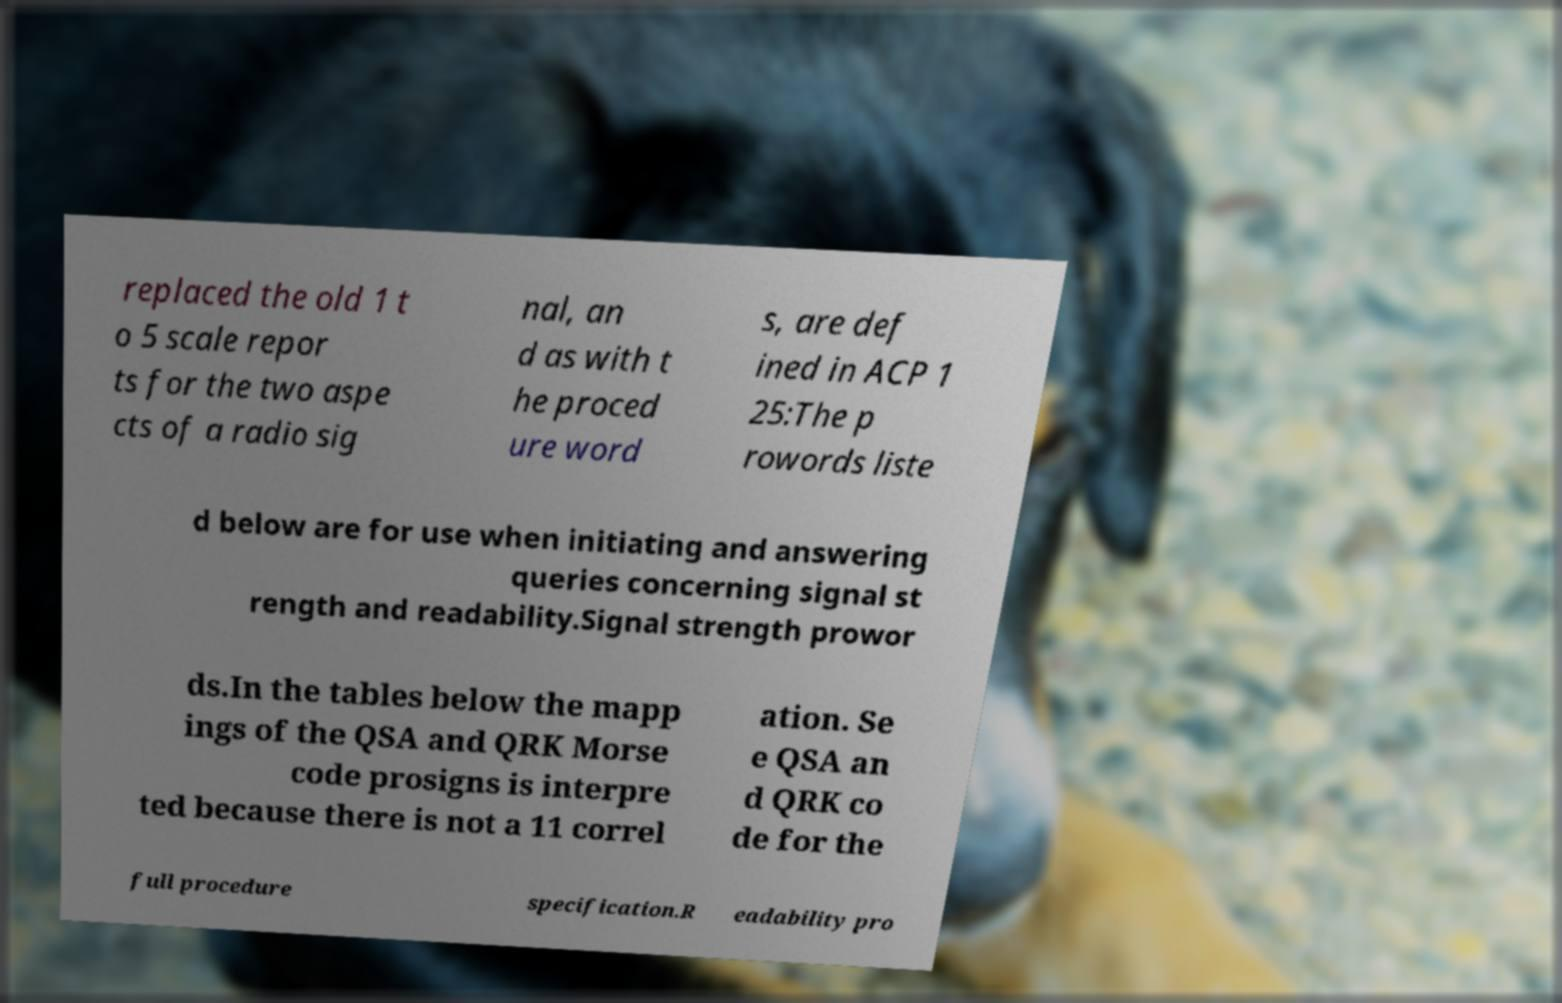There's text embedded in this image that I need extracted. Can you transcribe it verbatim? replaced the old 1 t o 5 scale repor ts for the two aspe cts of a radio sig nal, an d as with t he proced ure word s, are def ined in ACP 1 25:The p rowords liste d below are for use when initiating and answering queries concerning signal st rength and readability.Signal strength prowor ds.In the tables below the mapp ings of the QSA and QRK Morse code prosigns is interpre ted because there is not a 11 correl ation. Se e QSA an d QRK co de for the full procedure specification.R eadability pro 